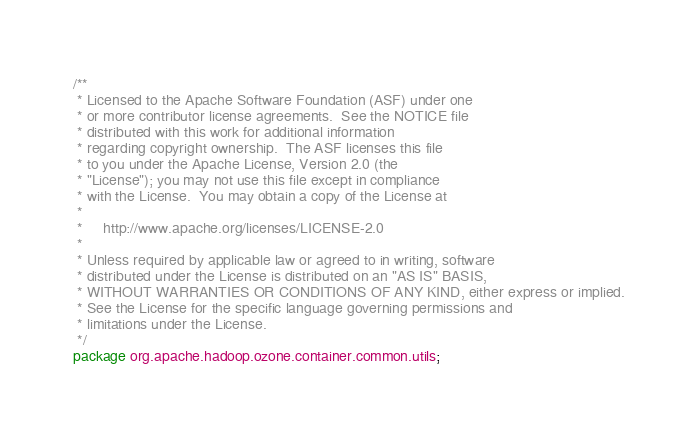<code> <loc_0><loc_0><loc_500><loc_500><_Java_>/**
 * Licensed to the Apache Software Foundation (ASF) under one
 * or more contributor license agreements.  See the NOTICE file
 * distributed with this work for additional information
 * regarding copyright ownership.  The ASF licenses this file
 * to you under the Apache License, Version 2.0 (the
 * "License"); you may not use this file except in compliance
 * with the License.  You may obtain a copy of the License at
 *
 *     http://www.apache.org/licenses/LICENSE-2.0
 *
 * Unless required by applicable law or agreed to in writing, software
 * distributed under the License is distributed on an "AS IS" BASIS,
 * WITHOUT WARRANTIES OR CONDITIONS OF ANY KIND, either express or implied.
 * See the License for the specific language governing permissions and
 * limitations under the License.
 */
package org.apache.hadoop.ozone.container.common.utils;</code> 